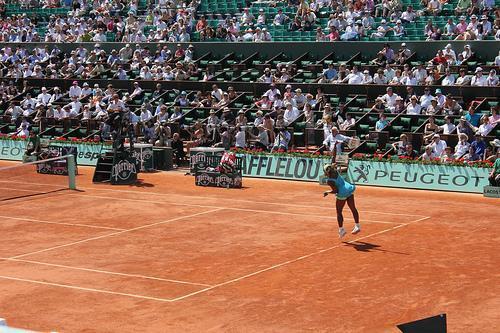How many women in blue?
Give a very brief answer. 1. 